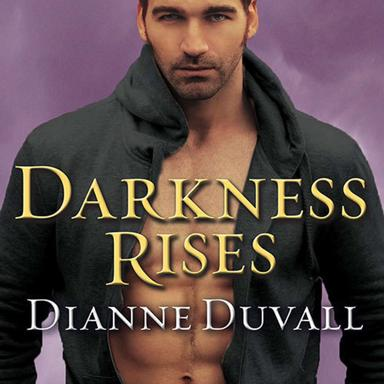What is "Darkness Rises"? "Darkness Rises" is a book written by Dianne Duvall. What genre does "Darkness Rises" fall under? "Darkness Rises" by Dianne Duvall is a paranormal romance novel. 